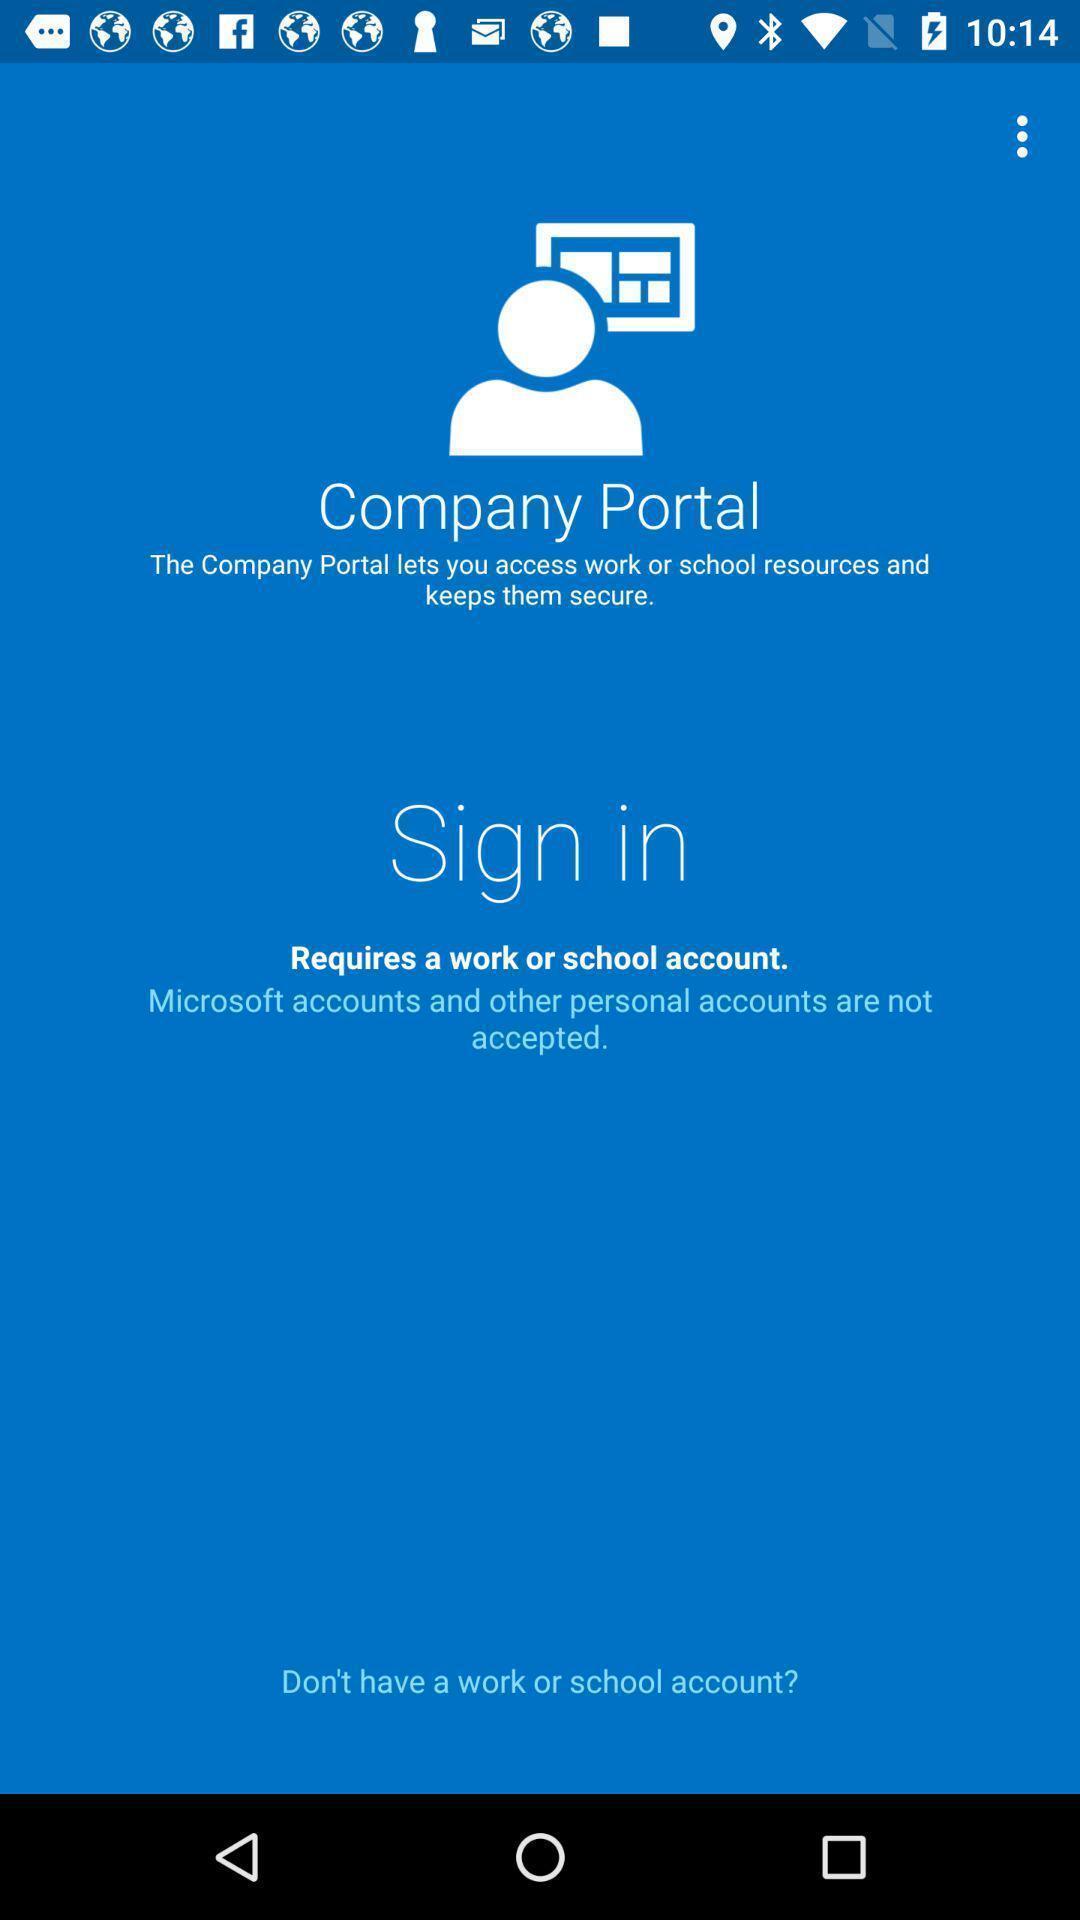Summarize the information in this screenshot. Welcome page for an application. 